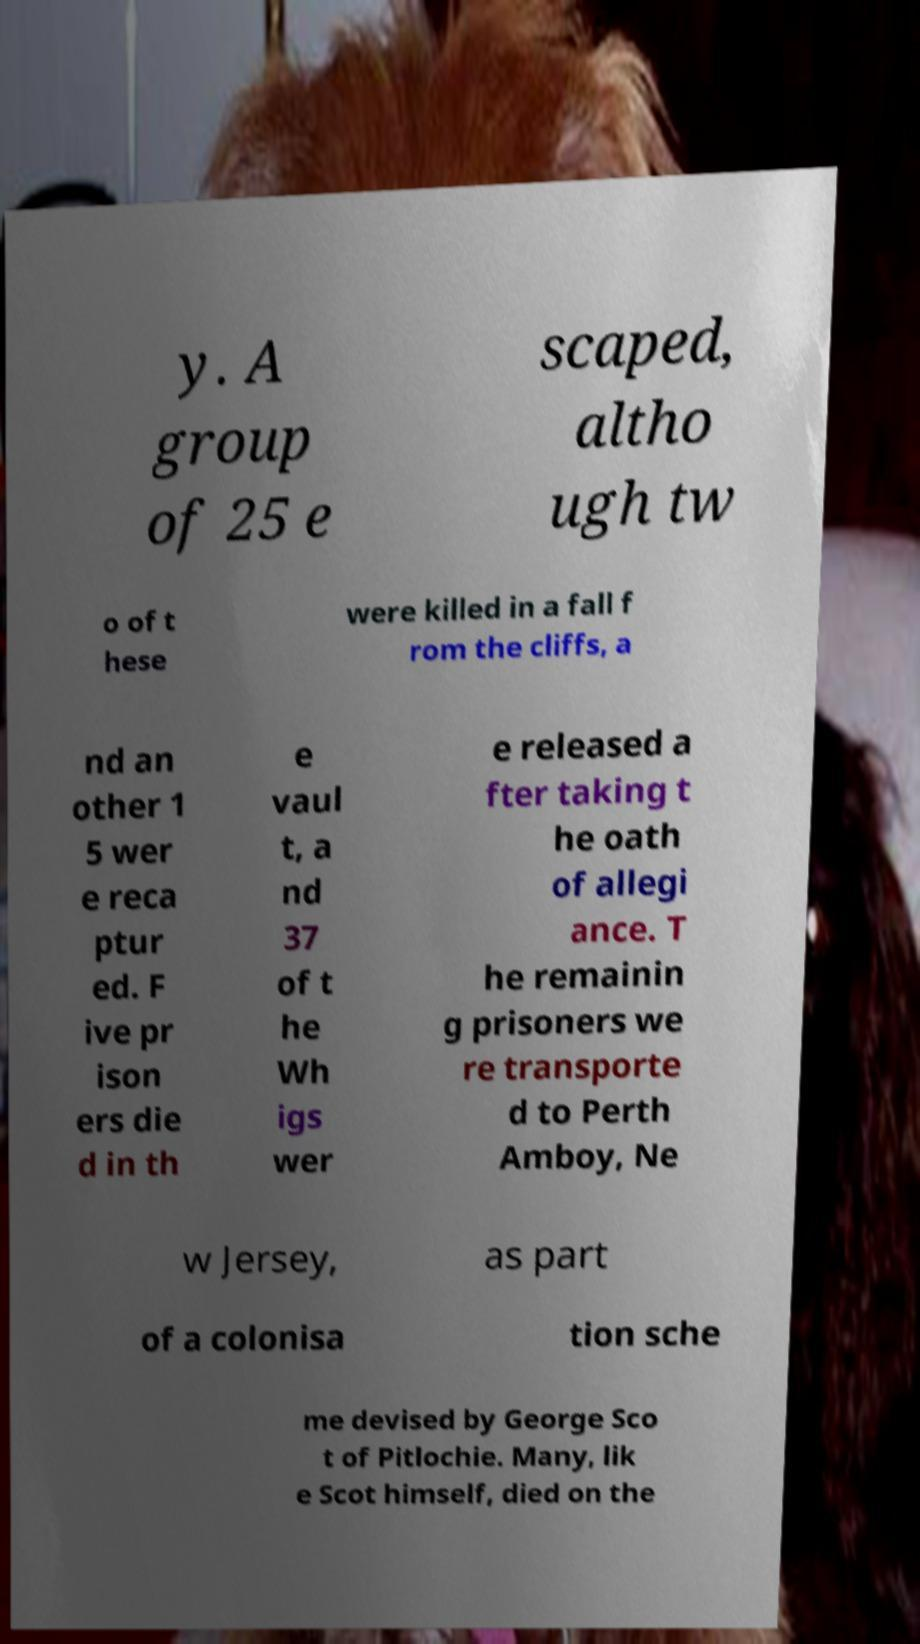Please read and relay the text visible in this image. What does it say? y. A group of 25 e scaped, altho ugh tw o of t hese were killed in a fall f rom the cliffs, a nd an other 1 5 wer e reca ptur ed. F ive pr ison ers die d in th e vaul t, a nd 37 of t he Wh igs wer e released a fter taking t he oath of allegi ance. T he remainin g prisoners we re transporte d to Perth Amboy, Ne w Jersey, as part of a colonisa tion sche me devised by George Sco t of Pitlochie. Many, lik e Scot himself, died on the 